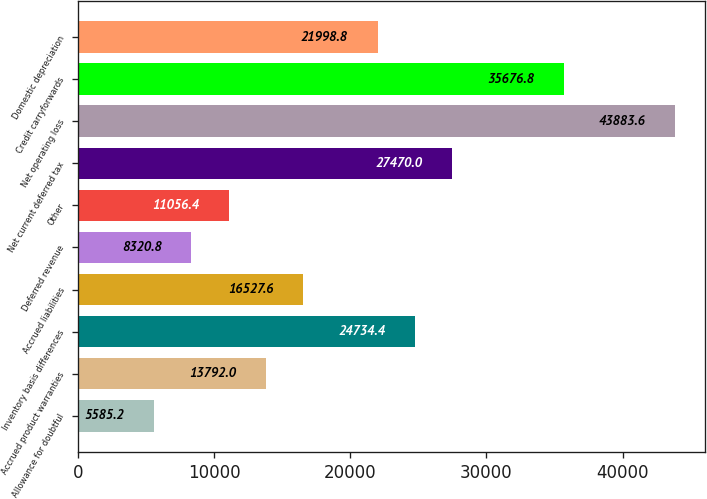<chart> <loc_0><loc_0><loc_500><loc_500><bar_chart><fcel>Allowance for doubtful<fcel>Accrued product warranties<fcel>Inventory basis differences<fcel>Accrued liabilities<fcel>Deferred revenue<fcel>Other<fcel>Net current deferred tax<fcel>Net operating loss<fcel>Credit carryforwards<fcel>Domestic depreciation<nl><fcel>5585.2<fcel>13792<fcel>24734.4<fcel>16527.6<fcel>8320.8<fcel>11056.4<fcel>27470<fcel>43883.6<fcel>35676.8<fcel>21998.8<nl></chart> 